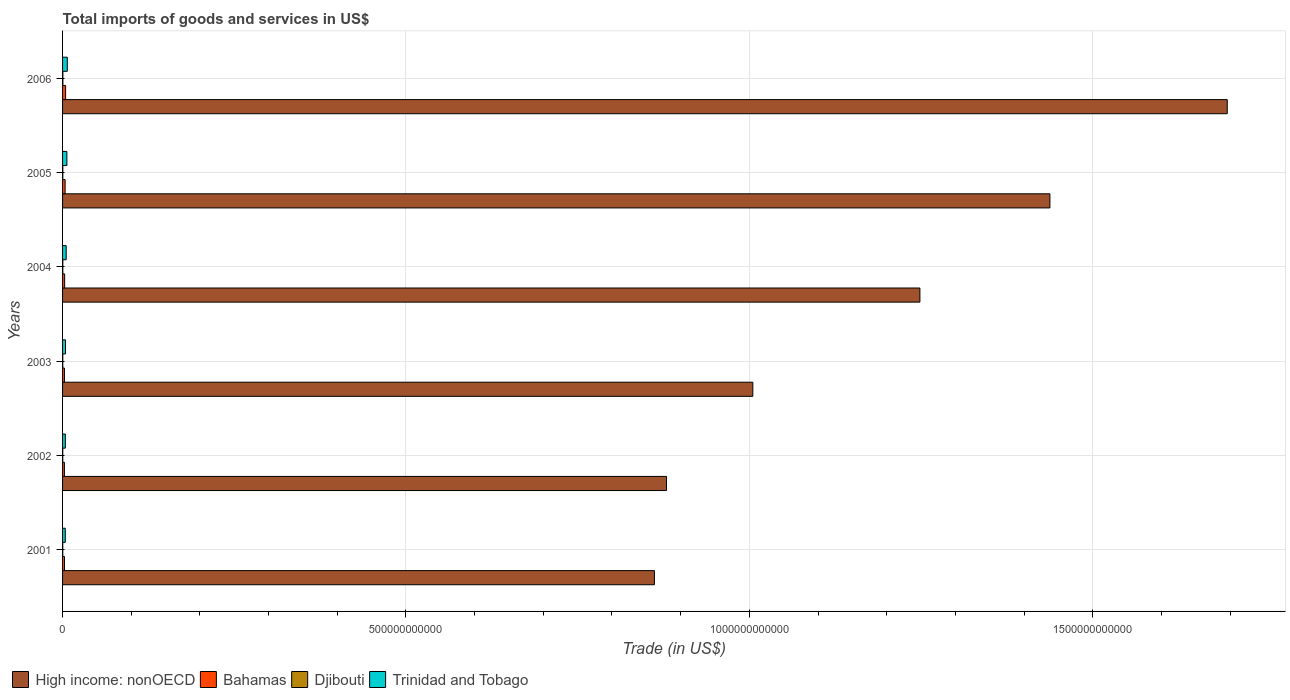How many different coloured bars are there?
Your answer should be very brief. 4. How many groups of bars are there?
Your answer should be very brief. 6. Are the number of bars on each tick of the Y-axis equal?
Give a very brief answer. Yes. How many bars are there on the 1st tick from the top?
Provide a short and direct response. 4. How many bars are there on the 4th tick from the bottom?
Offer a terse response. 4. What is the label of the 4th group of bars from the top?
Ensure brevity in your answer.  2003. What is the total imports of goods and services in Trinidad and Tobago in 2001?
Your answer should be compact. 3.96e+09. Across all years, what is the maximum total imports of goods and services in High income: nonOECD?
Provide a short and direct response. 1.70e+12. Across all years, what is the minimum total imports of goods and services in Trinidad and Tobago?
Provide a succinct answer. 3.96e+09. In which year was the total imports of goods and services in Bahamas minimum?
Make the answer very short. 2002. What is the total total imports of goods and services in Djibouti in the graph?
Give a very brief answer. 1.99e+09. What is the difference between the total imports of goods and services in Trinidad and Tobago in 2002 and that in 2003?
Your answer should be compact. -2.28e+08. What is the difference between the total imports of goods and services in High income: nonOECD in 2001 and the total imports of goods and services in Bahamas in 2002?
Provide a succinct answer. 8.59e+11. What is the average total imports of goods and services in Bahamas per year?
Offer a very short reply. 3.23e+09. In the year 2005, what is the difference between the total imports of goods and services in Djibouti and total imports of goods and services in High income: nonOECD?
Your answer should be compact. -1.44e+12. What is the ratio of the total imports of goods and services in Djibouti in 2002 to that in 2005?
Your response must be concise. 0.72. Is the difference between the total imports of goods and services in Djibouti in 2002 and 2003 greater than the difference between the total imports of goods and services in High income: nonOECD in 2002 and 2003?
Make the answer very short. Yes. What is the difference between the highest and the second highest total imports of goods and services in Bahamas?
Your answer should be compact. 7.17e+08. What is the difference between the highest and the lowest total imports of goods and services in High income: nonOECD?
Your answer should be compact. 8.34e+11. What does the 4th bar from the top in 2001 represents?
Your response must be concise. High income: nonOECD. What does the 3rd bar from the bottom in 2006 represents?
Give a very brief answer. Djibouti. Are all the bars in the graph horizontal?
Keep it short and to the point. Yes. How many years are there in the graph?
Offer a terse response. 6. What is the difference between two consecutive major ticks on the X-axis?
Your answer should be compact. 5.00e+11. Where does the legend appear in the graph?
Your response must be concise. Bottom left. What is the title of the graph?
Give a very brief answer. Total imports of goods and services in US$. What is the label or title of the X-axis?
Your response must be concise. Trade (in US$). What is the label or title of the Y-axis?
Provide a succinct answer. Years. What is the Trade (in US$) in High income: nonOECD in 2001?
Ensure brevity in your answer.  8.62e+11. What is the Trade (in US$) in Bahamas in 2001?
Provide a succinct answer. 2.82e+09. What is the Trade (in US$) in Djibouti in 2001?
Offer a very short reply. 2.62e+08. What is the Trade (in US$) of Trinidad and Tobago in 2001?
Your answer should be compact. 3.96e+09. What is the Trade (in US$) of High income: nonOECD in 2002?
Keep it short and to the point. 8.79e+11. What is the Trade (in US$) in Bahamas in 2002?
Provide a short and direct response. 2.67e+09. What is the Trade (in US$) in Djibouti in 2002?
Make the answer very short. 2.59e+08. What is the Trade (in US$) in Trinidad and Tobago in 2002?
Give a very brief answer. 4.06e+09. What is the Trade (in US$) of High income: nonOECD in 2003?
Provide a short and direct response. 1.01e+12. What is the Trade (in US$) of Bahamas in 2003?
Keep it short and to the point. 2.76e+09. What is the Trade (in US$) of Djibouti in 2003?
Your response must be concise. 3.05e+08. What is the Trade (in US$) of Trinidad and Tobago in 2003?
Your answer should be compact. 4.28e+09. What is the Trade (in US$) in High income: nonOECD in 2004?
Offer a very short reply. 1.25e+12. What is the Trade (in US$) in Bahamas in 2004?
Provide a short and direct response. 3.02e+09. What is the Trade (in US$) in Djibouti in 2004?
Your answer should be very brief. 3.61e+08. What is the Trade (in US$) in Trinidad and Tobago in 2004?
Make the answer very short. 5.26e+09. What is the Trade (in US$) in High income: nonOECD in 2005?
Keep it short and to the point. 1.44e+12. What is the Trade (in US$) in Bahamas in 2005?
Your response must be concise. 3.70e+09. What is the Trade (in US$) in Djibouti in 2005?
Your answer should be very brief. 3.61e+08. What is the Trade (in US$) of Trinidad and Tobago in 2005?
Provide a succinct answer. 6.27e+09. What is the Trade (in US$) in High income: nonOECD in 2006?
Ensure brevity in your answer.  1.70e+12. What is the Trade (in US$) of Bahamas in 2006?
Make the answer very short. 4.42e+09. What is the Trade (in US$) in Djibouti in 2006?
Keep it short and to the point. 4.41e+08. What is the Trade (in US$) in Trinidad and Tobago in 2006?
Your answer should be very brief. 6.88e+09. Across all years, what is the maximum Trade (in US$) in High income: nonOECD?
Your response must be concise. 1.70e+12. Across all years, what is the maximum Trade (in US$) in Bahamas?
Provide a short and direct response. 4.42e+09. Across all years, what is the maximum Trade (in US$) in Djibouti?
Your answer should be very brief. 4.41e+08. Across all years, what is the maximum Trade (in US$) in Trinidad and Tobago?
Give a very brief answer. 6.88e+09. Across all years, what is the minimum Trade (in US$) of High income: nonOECD?
Your answer should be very brief. 8.62e+11. Across all years, what is the minimum Trade (in US$) in Bahamas?
Offer a very short reply. 2.67e+09. Across all years, what is the minimum Trade (in US$) in Djibouti?
Offer a terse response. 2.59e+08. Across all years, what is the minimum Trade (in US$) in Trinidad and Tobago?
Make the answer very short. 3.96e+09. What is the total Trade (in US$) in High income: nonOECD in the graph?
Offer a very short reply. 7.13e+12. What is the total Trade (in US$) of Bahamas in the graph?
Provide a succinct answer. 1.94e+1. What is the total Trade (in US$) in Djibouti in the graph?
Provide a succinct answer. 1.99e+09. What is the total Trade (in US$) of Trinidad and Tobago in the graph?
Your answer should be very brief. 3.07e+1. What is the difference between the Trade (in US$) in High income: nonOECD in 2001 and that in 2002?
Your answer should be very brief. -1.76e+1. What is the difference between the Trade (in US$) of Bahamas in 2001 and that in 2002?
Your response must be concise. 1.48e+08. What is the difference between the Trade (in US$) of Djibouti in 2001 and that in 2002?
Give a very brief answer. 3.39e+06. What is the difference between the Trade (in US$) in Trinidad and Tobago in 2001 and that in 2002?
Ensure brevity in your answer.  -9.82e+07. What is the difference between the Trade (in US$) in High income: nonOECD in 2001 and that in 2003?
Make the answer very short. -1.43e+11. What is the difference between the Trade (in US$) of Bahamas in 2001 and that in 2003?
Offer a terse response. 6.12e+07. What is the difference between the Trade (in US$) in Djibouti in 2001 and that in 2003?
Give a very brief answer. -4.32e+07. What is the difference between the Trade (in US$) in Trinidad and Tobago in 2001 and that in 2003?
Offer a very short reply. -3.26e+08. What is the difference between the Trade (in US$) in High income: nonOECD in 2001 and that in 2004?
Offer a terse response. -3.87e+11. What is the difference between the Trade (in US$) in Bahamas in 2001 and that in 2004?
Your answer should be compact. -1.99e+08. What is the difference between the Trade (in US$) of Djibouti in 2001 and that in 2004?
Your response must be concise. -9.88e+07. What is the difference between the Trade (in US$) in Trinidad and Tobago in 2001 and that in 2004?
Provide a succinct answer. -1.31e+09. What is the difference between the Trade (in US$) in High income: nonOECD in 2001 and that in 2005?
Ensure brevity in your answer.  -5.76e+11. What is the difference between the Trade (in US$) in Bahamas in 2001 and that in 2005?
Your answer should be very brief. -8.80e+08. What is the difference between the Trade (in US$) in Djibouti in 2001 and that in 2005?
Your answer should be very brief. -9.91e+07. What is the difference between the Trade (in US$) of Trinidad and Tobago in 2001 and that in 2005?
Your answer should be very brief. -2.31e+09. What is the difference between the Trade (in US$) in High income: nonOECD in 2001 and that in 2006?
Offer a very short reply. -8.34e+11. What is the difference between the Trade (in US$) in Bahamas in 2001 and that in 2006?
Keep it short and to the point. -1.60e+09. What is the difference between the Trade (in US$) in Djibouti in 2001 and that in 2006?
Your answer should be very brief. -1.79e+08. What is the difference between the Trade (in US$) in Trinidad and Tobago in 2001 and that in 2006?
Ensure brevity in your answer.  -2.92e+09. What is the difference between the Trade (in US$) in High income: nonOECD in 2002 and that in 2003?
Provide a succinct answer. -1.26e+11. What is the difference between the Trade (in US$) of Bahamas in 2002 and that in 2003?
Give a very brief answer. -8.67e+07. What is the difference between the Trade (in US$) in Djibouti in 2002 and that in 2003?
Provide a succinct answer. -4.66e+07. What is the difference between the Trade (in US$) of Trinidad and Tobago in 2002 and that in 2003?
Keep it short and to the point. -2.28e+08. What is the difference between the Trade (in US$) in High income: nonOECD in 2002 and that in 2004?
Offer a very short reply. -3.69e+11. What is the difference between the Trade (in US$) in Bahamas in 2002 and that in 2004?
Ensure brevity in your answer.  -3.47e+08. What is the difference between the Trade (in US$) in Djibouti in 2002 and that in 2004?
Offer a very short reply. -1.02e+08. What is the difference between the Trade (in US$) of Trinidad and Tobago in 2002 and that in 2004?
Make the answer very short. -1.21e+09. What is the difference between the Trade (in US$) in High income: nonOECD in 2002 and that in 2005?
Make the answer very short. -5.58e+11. What is the difference between the Trade (in US$) of Bahamas in 2002 and that in 2005?
Offer a very short reply. -1.03e+09. What is the difference between the Trade (in US$) in Djibouti in 2002 and that in 2005?
Your response must be concise. -1.02e+08. What is the difference between the Trade (in US$) of Trinidad and Tobago in 2002 and that in 2005?
Keep it short and to the point. -2.21e+09. What is the difference between the Trade (in US$) in High income: nonOECD in 2002 and that in 2006?
Offer a terse response. -8.17e+11. What is the difference between the Trade (in US$) of Bahamas in 2002 and that in 2006?
Offer a very short reply. -1.74e+09. What is the difference between the Trade (in US$) of Djibouti in 2002 and that in 2006?
Provide a succinct answer. -1.82e+08. What is the difference between the Trade (in US$) in Trinidad and Tobago in 2002 and that in 2006?
Offer a terse response. -2.82e+09. What is the difference between the Trade (in US$) in High income: nonOECD in 2003 and that in 2004?
Your response must be concise. -2.43e+11. What is the difference between the Trade (in US$) in Bahamas in 2003 and that in 2004?
Your answer should be compact. -2.60e+08. What is the difference between the Trade (in US$) of Djibouti in 2003 and that in 2004?
Make the answer very short. -5.56e+07. What is the difference between the Trade (in US$) of Trinidad and Tobago in 2003 and that in 2004?
Ensure brevity in your answer.  -9.82e+08. What is the difference between the Trade (in US$) in High income: nonOECD in 2003 and that in 2005?
Your answer should be very brief. -4.33e+11. What is the difference between the Trade (in US$) of Bahamas in 2003 and that in 2005?
Your response must be concise. -9.41e+08. What is the difference between the Trade (in US$) of Djibouti in 2003 and that in 2005?
Make the answer very short. -5.59e+07. What is the difference between the Trade (in US$) in Trinidad and Tobago in 2003 and that in 2005?
Provide a short and direct response. -1.98e+09. What is the difference between the Trade (in US$) in High income: nonOECD in 2003 and that in 2006?
Offer a terse response. -6.91e+11. What is the difference between the Trade (in US$) in Bahamas in 2003 and that in 2006?
Your answer should be very brief. -1.66e+09. What is the difference between the Trade (in US$) of Djibouti in 2003 and that in 2006?
Provide a short and direct response. -1.36e+08. What is the difference between the Trade (in US$) of Trinidad and Tobago in 2003 and that in 2006?
Your answer should be compact. -2.60e+09. What is the difference between the Trade (in US$) of High income: nonOECD in 2004 and that in 2005?
Ensure brevity in your answer.  -1.89e+11. What is the difference between the Trade (in US$) of Bahamas in 2004 and that in 2005?
Provide a short and direct response. -6.81e+08. What is the difference between the Trade (in US$) in Djibouti in 2004 and that in 2005?
Offer a terse response. -3.00e+05. What is the difference between the Trade (in US$) of Trinidad and Tobago in 2004 and that in 2005?
Make the answer very short. -1.00e+09. What is the difference between the Trade (in US$) in High income: nonOECD in 2004 and that in 2006?
Offer a very short reply. -4.48e+11. What is the difference between the Trade (in US$) in Bahamas in 2004 and that in 2006?
Ensure brevity in your answer.  -1.40e+09. What is the difference between the Trade (in US$) of Djibouti in 2004 and that in 2006?
Ensure brevity in your answer.  -8.00e+07. What is the difference between the Trade (in US$) of Trinidad and Tobago in 2004 and that in 2006?
Make the answer very short. -1.61e+09. What is the difference between the Trade (in US$) in High income: nonOECD in 2005 and that in 2006?
Provide a succinct answer. -2.58e+11. What is the difference between the Trade (in US$) in Bahamas in 2005 and that in 2006?
Provide a succinct answer. -7.17e+08. What is the difference between the Trade (in US$) of Djibouti in 2005 and that in 2006?
Offer a very short reply. -7.97e+07. What is the difference between the Trade (in US$) of Trinidad and Tobago in 2005 and that in 2006?
Provide a short and direct response. -6.14e+08. What is the difference between the Trade (in US$) in High income: nonOECD in 2001 and the Trade (in US$) in Bahamas in 2002?
Give a very brief answer. 8.59e+11. What is the difference between the Trade (in US$) in High income: nonOECD in 2001 and the Trade (in US$) in Djibouti in 2002?
Give a very brief answer. 8.62e+11. What is the difference between the Trade (in US$) of High income: nonOECD in 2001 and the Trade (in US$) of Trinidad and Tobago in 2002?
Give a very brief answer. 8.58e+11. What is the difference between the Trade (in US$) in Bahamas in 2001 and the Trade (in US$) in Djibouti in 2002?
Offer a very short reply. 2.56e+09. What is the difference between the Trade (in US$) of Bahamas in 2001 and the Trade (in US$) of Trinidad and Tobago in 2002?
Offer a terse response. -1.24e+09. What is the difference between the Trade (in US$) in Djibouti in 2001 and the Trade (in US$) in Trinidad and Tobago in 2002?
Ensure brevity in your answer.  -3.79e+09. What is the difference between the Trade (in US$) of High income: nonOECD in 2001 and the Trade (in US$) of Bahamas in 2003?
Your answer should be compact. 8.59e+11. What is the difference between the Trade (in US$) of High income: nonOECD in 2001 and the Trade (in US$) of Djibouti in 2003?
Your response must be concise. 8.61e+11. What is the difference between the Trade (in US$) in High income: nonOECD in 2001 and the Trade (in US$) in Trinidad and Tobago in 2003?
Ensure brevity in your answer.  8.58e+11. What is the difference between the Trade (in US$) in Bahamas in 2001 and the Trade (in US$) in Djibouti in 2003?
Ensure brevity in your answer.  2.51e+09. What is the difference between the Trade (in US$) of Bahamas in 2001 and the Trade (in US$) of Trinidad and Tobago in 2003?
Your answer should be very brief. -1.46e+09. What is the difference between the Trade (in US$) of Djibouti in 2001 and the Trade (in US$) of Trinidad and Tobago in 2003?
Provide a short and direct response. -4.02e+09. What is the difference between the Trade (in US$) of High income: nonOECD in 2001 and the Trade (in US$) of Bahamas in 2004?
Provide a succinct answer. 8.59e+11. What is the difference between the Trade (in US$) in High income: nonOECD in 2001 and the Trade (in US$) in Djibouti in 2004?
Keep it short and to the point. 8.61e+11. What is the difference between the Trade (in US$) in High income: nonOECD in 2001 and the Trade (in US$) in Trinidad and Tobago in 2004?
Provide a succinct answer. 8.57e+11. What is the difference between the Trade (in US$) in Bahamas in 2001 and the Trade (in US$) in Djibouti in 2004?
Ensure brevity in your answer.  2.46e+09. What is the difference between the Trade (in US$) in Bahamas in 2001 and the Trade (in US$) in Trinidad and Tobago in 2004?
Keep it short and to the point. -2.44e+09. What is the difference between the Trade (in US$) in Djibouti in 2001 and the Trade (in US$) in Trinidad and Tobago in 2004?
Provide a short and direct response. -5.00e+09. What is the difference between the Trade (in US$) in High income: nonOECD in 2001 and the Trade (in US$) in Bahamas in 2005?
Your response must be concise. 8.58e+11. What is the difference between the Trade (in US$) of High income: nonOECD in 2001 and the Trade (in US$) of Djibouti in 2005?
Offer a very short reply. 8.61e+11. What is the difference between the Trade (in US$) of High income: nonOECD in 2001 and the Trade (in US$) of Trinidad and Tobago in 2005?
Provide a succinct answer. 8.56e+11. What is the difference between the Trade (in US$) of Bahamas in 2001 and the Trade (in US$) of Djibouti in 2005?
Keep it short and to the point. 2.46e+09. What is the difference between the Trade (in US$) in Bahamas in 2001 and the Trade (in US$) in Trinidad and Tobago in 2005?
Provide a succinct answer. -3.45e+09. What is the difference between the Trade (in US$) of Djibouti in 2001 and the Trade (in US$) of Trinidad and Tobago in 2005?
Your answer should be compact. -6.00e+09. What is the difference between the Trade (in US$) of High income: nonOECD in 2001 and the Trade (in US$) of Bahamas in 2006?
Offer a terse response. 8.57e+11. What is the difference between the Trade (in US$) in High income: nonOECD in 2001 and the Trade (in US$) in Djibouti in 2006?
Offer a terse response. 8.61e+11. What is the difference between the Trade (in US$) of High income: nonOECD in 2001 and the Trade (in US$) of Trinidad and Tobago in 2006?
Offer a very short reply. 8.55e+11. What is the difference between the Trade (in US$) of Bahamas in 2001 and the Trade (in US$) of Djibouti in 2006?
Offer a terse response. 2.38e+09. What is the difference between the Trade (in US$) in Bahamas in 2001 and the Trade (in US$) in Trinidad and Tobago in 2006?
Ensure brevity in your answer.  -4.06e+09. What is the difference between the Trade (in US$) of Djibouti in 2001 and the Trade (in US$) of Trinidad and Tobago in 2006?
Provide a succinct answer. -6.62e+09. What is the difference between the Trade (in US$) of High income: nonOECD in 2002 and the Trade (in US$) of Bahamas in 2003?
Make the answer very short. 8.77e+11. What is the difference between the Trade (in US$) in High income: nonOECD in 2002 and the Trade (in US$) in Djibouti in 2003?
Offer a very short reply. 8.79e+11. What is the difference between the Trade (in US$) of High income: nonOECD in 2002 and the Trade (in US$) of Trinidad and Tobago in 2003?
Keep it short and to the point. 8.75e+11. What is the difference between the Trade (in US$) of Bahamas in 2002 and the Trade (in US$) of Djibouti in 2003?
Offer a very short reply. 2.37e+09. What is the difference between the Trade (in US$) in Bahamas in 2002 and the Trade (in US$) in Trinidad and Tobago in 2003?
Offer a terse response. -1.61e+09. What is the difference between the Trade (in US$) in Djibouti in 2002 and the Trade (in US$) in Trinidad and Tobago in 2003?
Your answer should be very brief. -4.02e+09. What is the difference between the Trade (in US$) in High income: nonOECD in 2002 and the Trade (in US$) in Bahamas in 2004?
Ensure brevity in your answer.  8.76e+11. What is the difference between the Trade (in US$) of High income: nonOECD in 2002 and the Trade (in US$) of Djibouti in 2004?
Offer a very short reply. 8.79e+11. What is the difference between the Trade (in US$) of High income: nonOECD in 2002 and the Trade (in US$) of Trinidad and Tobago in 2004?
Offer a very short reply. 8.74e+11. What is the difference between the Trade (in US$) in Bahamas in 2002 and the Trade (in US$) in Djibouti in 2004?
Offer a terse response. 2.31e+09. What is the difference between the Trade (in US$) of Bahamas in 2002 and the Trade (in US$) of Trinidad and Tobago in 2004?
Provide a succinct answer. -2.59e+09. What is the difference between the Trade (in US$) of Djibouti in 2002 and the Trade (in US$) of Trinidad and Tobago in 2004?
Make the answer very short. -5.01e+09. What is the difference between the Trade (in US$) of High income: nonOECD in 2002 and the Trade (in US$) of Bahamas in 2005?
Give a very brief answer. 8.76e+11. What is the difference between the Trade (in US$) in High income: nonOECD in 2002 and the Trade (in US$) in Djibouti in 2005?
Offer a very short reply. 8.79e+11. What is the difference between the Trade (in US$) of High income: nonOECD in 2002 and the Trade (in US$) of Trinidad and Tobago in 2005?
Ensure brevity in your answer.  8.73e+11. What is the difference between the Trade (in US$) of Bahamas in 2002 and the Trade (in US$) of Djibouti in 2005?
Keep it short and to the point. 2.31e+09. What is the difference between the Trade (in US$) of Bahamas in 2002 and the Trade (in US$) of Trinidad and Tobago in 2005?
Your answer should be very brief. -3.59e+09. What is the difference between the Trade (in US$) in Djibouti in 2002 and the Trade (in US$) in Trinidad and Tobago in 2005?
Ensure brevity in your answer.  -6.01e+09. What is the difference between the Trade (in US$) of High income: nonOECD in 2002 and the Trade (in US$) of Bahamas in 2006?
Keep it short and to the point. 8.75e+11. What is the difference between the Trade (in US$) in High income: nonOECD in 2002 and the Trade (in US$) in Djibouti in 2006?
Your answer should be compact. 8.79e+11. What is the difference between the Trade (in US$) in High income: nonOECD in 2002 and the Trade (in US$) in Trinidad and Tobago in 2006?
Provide a succinct answer. 8.73e+11. What is the difference between the Trade (in US$) of Bahamas in 2002 and the Trade (in US$) of Djibouti in 2006?
Offer a terse response. 2.23e+09. What is the difference between the Trade (in US$) of Bahamas in 2002 and the Trade (in US$) of Trinidad and Tobago in 2006?
Provide a succinct answer. -4.21e+09. What is the difference between the Trade (in US$) in Djibouti in 2002 and the Trade (in US$) in Trinidad and Tobago in 2006?
Provide a succinct answer. -6.62e+09. What is the difference between the Trade (in US$) of High income: nonOECD in 2003 and the Trade (in US$) of Bahamas in 2004?
Make the answer very short. 1.00e+12. What is the difference between the Trade (in US$) of High income: nonOECD in 2003 and the Trade (in US$) of Djibouti in 2004?
Ensure brevity in your answer.  1.00e+12. What is the difference between the Trade (in US$) of High income: nonOECD in 2003 and the Trade (in US$) of Trinidad and Tobago in 2004?
Offer a very short reply. 1.00e+12. What is the difference between the Trade (in US$) of Bahamas in 2003 and the Trade (in US$) of Djibouti in 2004?
Offer a very short reply. 2.40e+09. What is the difference between the Trade (in US$) of Bahamas in 2003 and the Trade (in US$) of Trinidad and Tobago in 2004?
Keep it short and to the point. -2.51e+09. What is the difference between the Trade (in US$) in Djibouti in 2003 and the Trade (in US$) in Trinidad and Tobago in 2004?
Your answer should be very brief. -4.96e+09. What is the difference between the Trade (in US$) of High income: nonOECD in 2003 and the Trade (in US$) of Bahamas in 2005?
Offer a terse response. 1.00e+12. What is the difference between the Trade (in US$) in High income: nonOECD in 2003 and the Trade (in US$) in Djibouti in 2005?
Offer a terse response. 1.00e+12. What is the difference between the Trade (in US$) in High income: nonOECD in 2003 and the Trade (in US$) in Trinidad and Tobago in 2005?
Keep it short and to the point. 9.99e+11. What is the difference between the Trade (in US$) in Bahamas in 2003 and the Trade (in US$) in Djibouti in 2005?
Ensure brevity in your answer.  2.40e+09. What is the difference between the Trade (in US$) in Bahamas in 2003 and the Trade (in US$) in Trinidad and Tobago in 2005?
Offer a terse response. -3.51e+09. What is the difference between the Trade (in US$) in Djibouti in 2003 and the Trade (in US$) in Trinidad and Tobago in 2005?
Make the answer very short. -5.96e+09. What is the difference between the Trade (in US$) in High income: nonOECD in 2003 and the Trade (in US$) in Bahamas in 2006?
Your answer should be compact. 1.00e+12. What is the difference between the Trade (in US$) in High income: nonOECD in 2003 and the Trade (in US$) in Djibouti in 2006?
Your answer should be very brief. 1.00e+12. What is the difference between the Trade (in US$) in High income: nonOECD in 2003 and the Trade (in US$) in Trinidad and Tobago in 2006?
Your answer should be very brief. 9.98e+11. What is the difference between the Trade (in US$) in Bahamas in 2003 and the Trade (in US$) in Djibouti in 2006?
Your answer should be compact. 2.32e+09. What is the difference between the Trade (in US$) of Bahamas in 2003 and the Trade (in US$) of Trinidad and Tobago in 2006?
Provide a short and direct response. -4.12e+09. What is the difference between the Trade (in US$) in Djibouti in 2003 and the Trade (in US$) in Trinidad and Tobago in 2006?
Offer a terse response. -6.57e+09. What is the difference between the Trade (in US$) in High income: nonOECD in 2004 and the Trade (in US$) in Bahamas in 2005?
Provide a short and direct response. 1.24e+12. What is the difference between the Trade (in US$) in High income: nonOECD in 2004 and the Trade (in US$) in Djibouti in 2005?
Your response must be concise. 1.25e+12. What is the difference between the Trade (in US$) of High income: nonOECD in 2004 and the Trade (in US$) of Trinidad and Tobago in 2005?
Your answer should be very brief. 1.24e+12. What is the difference between the Trade (in US$) in Bahamas in 2004 and the Trade (in US$) in Djibouti in 2005?
Provide a succinct answer. 2.66e+09. What is the difference between the Trade (in US$) of Bahamas in 2004 and the Trade (in US$) of Trinidad and Tobago in 2005?
Offer a very short reply. -3.25e+09. What is the difference between the Trade (in US$) of Djibouti in 2004 and the Trade (in US$) of Trinidad and Tobago in 2005?
Ensure brevity in your answer.  -5.90e+09. What is the difference between the Trade (in US$) in High income: nonOECD in 2004 and the Trade (in US$) in Bahamas in 2006?
Offer a terse response. 1.24e+12. What is the difference between the Trade (in US$) of High income: nonOECD in 2004 and the Trade (in US$) of Djibouti in 2006?
Provide a short and direct response. 1.25e+12. What is the difference between the Trade (in US$) in High income: nonOECD in 2004 and the Trade (in US$) in Trinidad and Tobago in 2006?
Keep it short and to the point. 1.24e+12. What is the difference between the Trade (in US$) of Bahamas in 2004 and the Trade (in US$) of Djibouti in 2006?
Keep it short and to the point. 2.58e+09. What is the difference between the Trade (in US$) of Bahamas in 2004 and the Trade (in US$) of Trinidad and Tobago in 2006?
Make the answer very short. -3.86e+09. What is the difference between the Trade (in US$) in Djibouti in 2004 and the Trade (in US$) in Trinidad and Tobago in 2006?
Ensure brevity in your answer.  -6.52e+09. What is the difference between the Trade (in US$) of High income: nonOECD in 2005 and the Trade (in US$) of Bahamas in 2006?
Offer a terse response. 1.43e+12. What is the difference between the Trade (in US$) in High income: nonOECD in 2005 and the Trade (in US$) in Djibouti in 2006?
Ensure brevity in your answer.  1.44e+12. What is the difference between the Trade (in US$) of High income: nonOECD in 2005 and the Trade (in US$) of Trinidad and Tobago in 2006?
Make the answer very short. 1.43e+12. What is the difference between the Trade (in US$) in Bahamas in 2005 and the Trade (in US$) in Djibouti in 2006?
Provide a succinct answer. 3.26e+09. What is the difference between the Trade (in US$) of Bahamas in 2005 and the Trade (in US$) of Trinidad and Tobago in 2006?
Provide a succinct answer. -3.18e+09. What is the difference between the Trade (in US$) in Djibouti in 2005 and the Trade (in US$) in Trinidad and Tobago in 2006?
Keep it short and to the point. -6.52e+09. What is the average Trade (in US$) in High income: nonOECD per year?
Provide a short and direct response. 1.19e+12. What is the average Trade (in US$) in Bahamas per year?
Ensure brevity in your answer.  3.23e+09. What is the average Trade (in US$) of Djibouti per year?
Offer a very short reply. 3.31e+08. What is the average Trade (in US$) in Trinidad and Tobago per year?
Offer a very short reply. 5.12e+09. In the year 2001, what is the difference between the Trade (in US$) in High income: nonOECD and Trade (in US$) in Bahamas?
Your answer should be compact. 8.59e+11. In the year 2001, what is the difference between the Trade (in US$) in High income: nonOECD and Trade (in US$) in Djibouti?
Give a very brief answer. 8.62e+11. In the year 2001, what is the difference between the Trade (in US$) in High income: nonOECD and Trade (in US$) in Trinidad and Tobago?
Keep it short and to the point. 8.58e+11. In the year 2001, what is the difference between the Trade (in US$) in Bahamas and Trade (in US$) in Djibouti?
Your answer should be very brief. 2.56e+09. In the year 2001, what is the difference between the Trade (in US$) in Bahamas and Trade (in US$) in Trinidad and Tobago?
Make the answer very short. -1.14e+09. In the year 2001, what is the difference between the Trade (in US$) in Djibouti and Trade (in US$) in Trinidad and Tobago?
Ensure brevity in your answer.  -3.70e+09. In the year 2002, what is the difference between the Trade (in US$) in High income: nonOECD and Trade (in US$) in Bahamas?
Provide a succinct answer. 8.77e+11. In the year 2002, what is the difference between the Trade (in US$) of High income: nonOECD and Trade (in US$) of Djibouti?
Your response must be concise. 8.79e+11. In the year 2002, what is the difference between the Trade (in US$) of High income: nonOECD and Trade (in US$) of Trinidad and Tobago?
Offer a very short reply. 8.75e+11. In the year 2002, what is the difference between the Trade (in US$) in Bahamas and Trade (in US$) in Djibouti?
Make the answer very short. 2.41e+09. In the year 2002, what is the difference between the Trade (in US$) of Bahamas and Trade (in US$) of Trinidad and Tobago?
Your response must be concise. -1.38e+09. In the year 2002, what is the difference between the Trade (in US$) in Djibouti and Trade (in US$) in Trinidad and Tobago?
Provide a short and direct response. -3.80e+09. In the year 2003, what is the difference between the Trade (in US$) in High income: nonOECD and Trade (in US$) in Bahamas?
Ensure brevity in your answer.  1.00e+12. In the year 2003, what is the difference between the Trade (in US$) in High income: nonOECD and Trade (in US$) in Djibouti?
Your answer should be compact. 1.00e+12. In the year 2003, what is the difference between the Trade (in US$) in High income: nonOECD and Trade (in US$) in Trinidad and Tobago?
Your answer should be very brief. 1.00e+12. In the year 2003, what is the difference between the Trade (in US$) of Bahamas and Trade (in US$) of Djibouti?
Your answer should be compact. 2.45e+09. In the year 2003, what is the difference between the Trade (in US$) of Bahamas and Trade (in US$) of Trinidad and Tobago?
Provide a succinct answer. -1.52e+09. In the year 2003, what is the difference between the Trade (in US$) of Djibouti and Trade (in US$) of Trinidad and Tobago?
Your answer should be compact. -3.98e+09. In the year 2004, what is the difference between the Trade (in US$) of High income: nonOECD and Trade (in US$) of Bahamas?
Your answer should be very brief. 1.25e+12. In the year 2004, what is the difference between the Trade (in US$) of High income: nonOECD and Trade (in US$) of Djibouti?
Give a very brief answer. 1.25e+12. In the year 2004, what is the difference between the Trade (in US$) in High income: nonOECD and Trade (in US$) in Trinidad and Tobago?
Ensure brevity in your answer.  1.24e+12. In the year 2004, what is the difference between the Trade (in US$) of Bahamas and Trade (in US$) of Djibouti?
Your response must be concise. 2.66e+09. In the year 2004, what is the difference between the Trade (in US$) of Bahamas and Trade (in US$) of Trinidad and Tobago?
Offer a very short reply. -2.25e+09. In the year 2004, what is the difference between the Trade (in US$) of Djibouti and Trade (in US$) of Trinidad and Tobago?
Keep it short and to the point. -4.90e+09. In the year 2005, what is the difference between the Trade (in US$) of High income: nonOECD and Trade (in US$) of Bahamas?
Offer a terse response. 1.43e+12. In the year 2005, what is the difference between the Trade (in US$) of High income: nonOECD and Trade (in US$) of Djibouti?
Your response must be concise. 1.44e+12. In the year 2005, what is the difference between the Trade (in US$) in High income: nonOECD and Trade (in US$) in Trinidad and Tobago?
Give a very brief answer. 1.43e+12. In the year 2005, what is the difference between the Trade (in US$) of Bahamas and Trade (in US$) of Djibouti?
Offer a very short reply. 3.34e+09. In the year 2005, what is the difference between the Trade (in US$) of Bahamas and Trade (in US$) of Trinidad and Tobago?
Provide a short and direct response. -2.57e+09. In the year 2005, what is the difference between the Trade (in US$) in Djibouti and Trade (in US$) in Trinidad and Tobago?
Provide a succinct answer. -5.90e+09. In the year 2006, what is the difference between the Trade (in US$) of High income: nonOECD and Trade (in US$) of Bahamas?
Provide a succinct answer. 1.69e+12. In the year 2006, what is the difference between the Trade (in US$) of High income: nonOECD and Trade (in US$) of Djibouti?
Provide a short and direct response. 1.70e+12. In the year 2006, what is the difference between the Trade (in US$) in High income: nonOECD and Trade (in US$) in Trinidad and Tobago?
Provide a short and direct response. 1.69e+12. In the year 2006, what is the difference between the Trade (in US$) in Bahamas and Trade (in US$) in Djibouti?
Ensure brevity in your answer.  3.98e+09. In the year 2006, what is the difference between the Trade (in US$) of Bahamas and Trade (in US$) of Trinidad and Tobago?
Make the answer very short. -2.46e+09. In the year 2006, what is the difference between the Trade (in US$) of Djibouti and Trade (in US$) of Trinidad and Tobago?
Your answer should be compact. -6.44e+09. What is the ratio of the Trade (in US$) in Bahamas in 2001 to that in 2002?
Your response must be concise. 1.06. What is the ratio of the Trade (in US$) in Djibouti in 2001 to that in 2002?
Offer a very short reply. 1.01. What is the ratio of the Trade (in US$) in Trinidad and Tobago in 2001 to that in 2002?
Make the answer very short. 0.98. What is the ratio of the Trade (in US$) of High income: nonOECD in 2001 to that in 2003?
Your answer should be very brief. 0.86. What is the ratio of the Trade (in US$) in Bahamas in 2001 to that in 2003?
Keep it short and to the point. 1.02. What is the ratio of the Trade (in US$) in Djibouti in 2001 to that in 2003?
Give a very brief answer. 0.86. What is the ratio of the Trade (in US$) in Trinidad and Tobago in 2001 to that in 2003?
Give a very brief answer. 0.92. What is the ratio of the Trade (in US$) in High income: nonOECD in 2001 to that in 2004?
Make the answer very short. 0.69. What is the ratio of the Trade (in US$) in Bahamas in 2001 to that in 2004?
Provide a succinct answer. 0.93. What is the ratio of the Trade (in US$) of Djibouti in 2001 to that in 2004?
Offer a terse response. 0.73. What is the ratio of the Trade (in US$) in Trinidad and Tobago in 2001 to that in 2004?
Provide a succinct answer. 0.75. What is the ratio of the Trade (in US$) of High income: nonOECD in 2001 to that in 2005?
Your answer should be compact. 0.6. What is the ratio of the Trade (in US$) of Bahamas in 2001 to that in 2005?
Offer a very short reply. 0.76. What is the ratio of the Trade (in US$) of Djibouti in 2001 to that in 2005?
Make the answer very short. 0.73. What is the ratio of the Trade (in US$) of Trinidad and Tobago in 2001 to that in 2005?
Provide a succinct answer. 0.63. What is the ratio of the Trade (in US$) of High income: nonOECD in 2001 to that in 2006?
Your answer should be compact. 0.51. What is the ratio of the Trade (in US$) of Bahamas in 2001 to that in 2006?
Offer a terse response. 0.64. What is the ratio of the Trade (in US$) in Djibouti in 2001 to that in 2006?
Provide a succinct answer. 0.59. What is the ratio of the Trade (in US$) in Trinidad and Tobago in 2001 to that in 2006?
Offer a terse response. 0.58. What is the ratio of the Trade (in US$) in High income: nonOECD in 2002 to that in 2003?
Offer a very short reply. 0.87. What is the ratio of the Trade (in US$) in Bahamas in 2002 to that in 2003?
Make the answer very short. 0.97. What is the ratio of the Trade (in US$) in Djibouti in 2002 to that in 2003?
Your answer should be very brief. 0.85. What is the ratio of the Trade (in US$) of Trinidad and Tobago in 2002 to that in 2003?
Your answer should be compact. 0.95. What is the ratio of the Trade (in US$) in High income: nonOECD in 2002 to that in 2004?
Ensure brevity in your answer.  0.7. What is the ratio of the Trade (in US$) in Bahamas in 2002 to that in 2004?
Offer a very short reply. 0.89. What is the ratio of the Trade (in US$) in Djibouti in 2002 to that in 2004?
Make the answer very short. 0.72. What is the ratio of the Trade (in US$) in Trinidad and Tobago in 2002 to that in 2004?
Make the answer very short. 0.77. What is the ratio of the Trade (in US$) in High income: nonOECD in 2002 to that in 2005?
Offer a terse response. 0.61. What is the ratio of the Trade (in US$) in Bahamas in 2002 to that in 2005?
Make the answer very short. 0.72. What is the ratio of the Trade (in US$) of Djibouti in 2002 to that in 2005?
Your answer should be compact. 0.72. What is the ratio of the Trade (in US$) in Trinidad and Tobago in 2002 to that in 2005?
Your answer should be compact. 0.65. What is the ratio of the Trade (in US$) in High income: nonOECD in 2002 to that in 2006?
Your answer should be compact. 0.52. What is the ratio of the Trade (in US$) of Bahamas in 2002 to that in 2006?
Make the answer very short. 0.6. What is the ratio of the Trade (in US$) in Djibouti in 2002 to that in 2006?
Keep it short and to the point. 0.59. What is the ratio of the Trade (in US$) of Trinidad and Tobago in 2002 to that in 2006?
Make the answer very short. 0.59. What is the ratio of the Trade (in US$) in High income: nonOECD in 2003 to that in 2004?
Ensure brevity in your answer.  0.81. What is the ratio of the Trade (in US$) of Bahamas in 2003 to that in 2004?
Make the answer very short. 0.91. What is the ratio of the Trade (in US$) of Djibouti in 2003 to that in 2004?
Provide a short and direct response. 0.85. What is the ratio of the Trade (in US$) of Trinidad and Tobago in 2003 to that in 2004?
Your answer should be very brief. 0.81. What is the ratio of the Trade (in US$) of High income: nonOECD in 2003 to that in 2005?
Make the answer very short. 0.7. What is the ratio of the Trade (in US$) of Bahamas in 2003 to that in 2005?
Your answer should be compact. 0.75. What is the ratio of the Trade (in US$) in Djibouti in 2003 to that in 2005?
Provide a short and direct response. 0.85. What is the ratio of the Trade (in US$) of Trinidad and Tobago in 2003 to that in 2005?
Your response must be concise. 0.68. What is the ratio of the Trade (in US$) of High income: nonOECD in 2003 to that in 2006?
Your answer should be very brief. 0.59. What is the ratio of the Trade (in US$) in Bahamas in 2003 to that in 2006?
Your answer should be very brief. 0.62. What is the ratio of the Trade (in US$) in Djibouti in 2003 to that in 2006?
Your answer should be very brief. 0.69. What is the ratio of the Trade (in US$) in Trinidad and Tobago in 2003 to that in 2006?
Your answer should be compact. 0.62. What is the ratio of the Trade (in US$) in High income: nonOECD in 2004 to that in 2005?
Provide a succinct answer. 0.87. What is the ratio of the Trade (in US$) in Bahamas in 2004 to that in 2005?
Offer a very short reply. 0.82. What is the ratio of the Trade (in US$) in Djibouti in 2004 to that in 2005?
Give a very brief answer. 1. What is the ratio of the Trade (in US$) in Trinidad and Tobago in 2004 to that in 2005?
Your answer should be very brief. 0.84. What is the ratio of the Trade (in US$) of High income: nonOECD in 2004 to that in 2006?
Offer a very short reply. 0.74. What is the ratio of the Trade (in US$) of Bahamas in 2004 to that in 2006?
Provide a short and direct response. 0.68. What is the ratio of the Trade (in US$) in Djibouti in 2004 to that in 2006?
Offer a very short reply. 0.82. What is the ratio of the Trade (in US$) in Trinidad and Tobago in 2004 to that in 2006?
Ensure brevity in your answer.  0.77. What is the ratio of the Trade (in US$) in High income: nonOECD in 2005 to that in 2006?
Offer a terse response. 0.85. What is the ratio of the Trade (in US$) in Bahamas in 2005 to that in 2006?
Your response must be concise. 0.84. What is the ratio of the Trade (in US$) in Djibouti in 2005 to that in 2006?
Provide a succinct answer. 0.82. What is the ratio of the Trade (in US$) of Trinidad and Tobago in 2005 to that in 2006?
Keep it short and to the point. 0.91. What is the difference between the highest and the second highest Trade (in US$) in High income: nonOECD?
Provide a short and direct response. 2.58e+11. What is the difference between the highest and the second highest Trade (in US$) in Bahamas?
Keep it short and to the point. 7.17e+08. What is the difference between the highest and the second highest Trade (in US$) of Djibouti?
Offer a terse response. 7.97e+07. What is the difference between the highest and the second highest Trade (in US$) in Trinidad and Tobago?
Make the answer very short. 6.14e+08. What is the difference between the highest and the lowest Trade (in US$) in High income: nonOECD?
Provide a short and direct response. 8.34e+11. What is the difference between the highest and the lowest Trade (in US$) of Bahamas?
Provide a succinct answer. 1.74e+09. What is the difference between the highest and the lowest Trade (in US$) in Djibouti?
Make the answer very short. 1.82e+08. What is the difference between the highest and the lowest Trade (in US$) in Trinidad and Tobago?
Your response must be concise. 2.92e+09. 